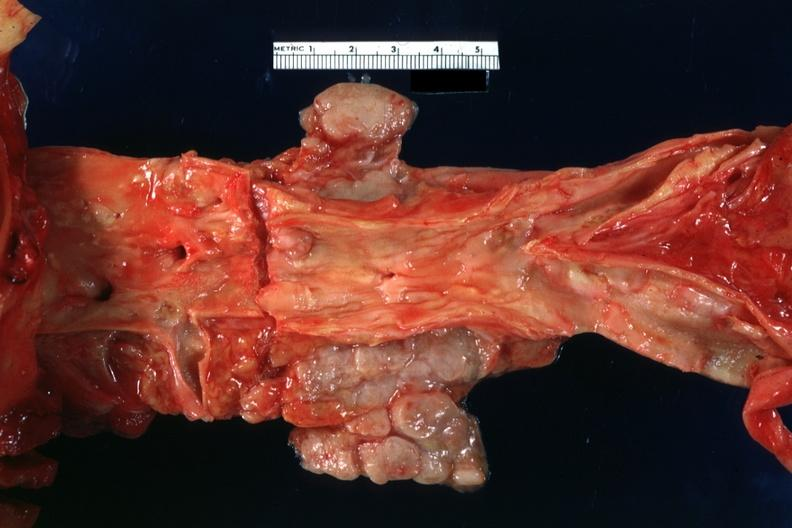what does this image show?
Answer the question using a single word or phrase. Periaortic nodes with metastatic carcinoma aorta shows good atherosclerotic plaques 